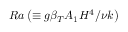Convert formula to latex. <formula><loc_0><loc_0><loc_500><loc_500>R a \left ( \equiv g \beta _ { T } A _ { 1 } H ^ { 4 } / \nu k \right )</formula> 